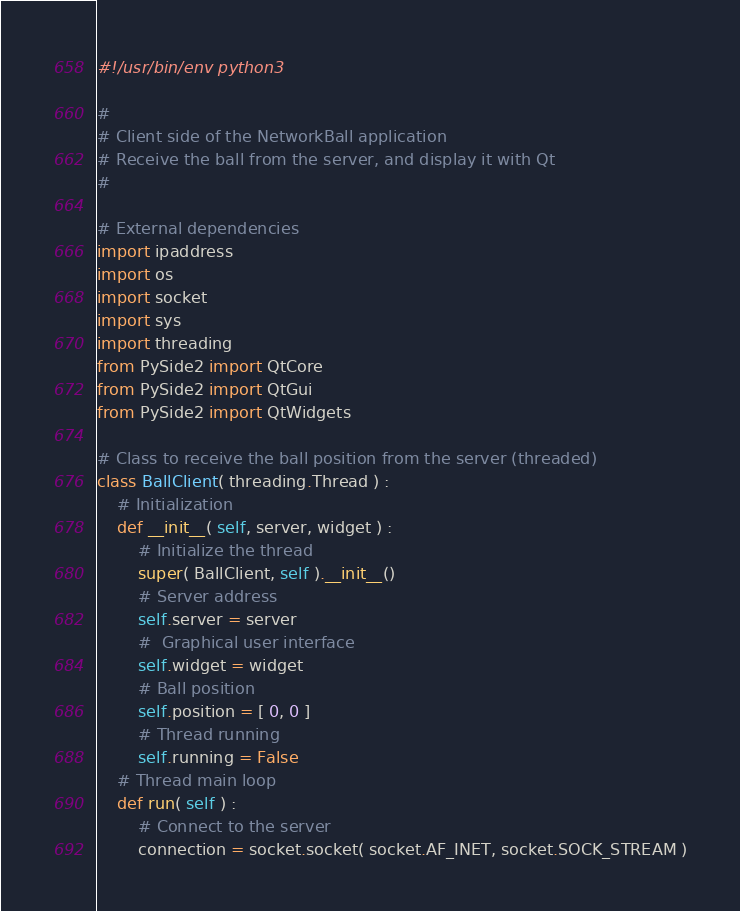<code> <loc_0><loc_0><loc_500><loc_500><_Python_>#!/usr/bin/env python3

#
# Client side of the NetworkBall application
# Receive the ball from the server, and display it with Qt
#

# External dependencies
import ipaddress
import os
import socket
import sys
import threading
from PySide2 import QtCore
from PySide2 import QtGui
from PySide2 import QtWidgets

# Class to receive the ball position from the server (threaded)
class BallClient( threading.Thread ) :
	# Initialization
	def __init__( self, server, widget ) :
		# Initialize the thread
		super( BallClient, self ).__init__()
		# Server address
		self.server = server
		# Graphical user interface
		self.widget = widget
		# Ball position
		self.position = [ 0, 0 ]
		# Thread running
		self.running = False
	# Thread main loop
	def run( self ) :
		# Connect to the server
		connection = socket.socket( socket.AF_INET, socket.SOCK_STREAM )</code> 